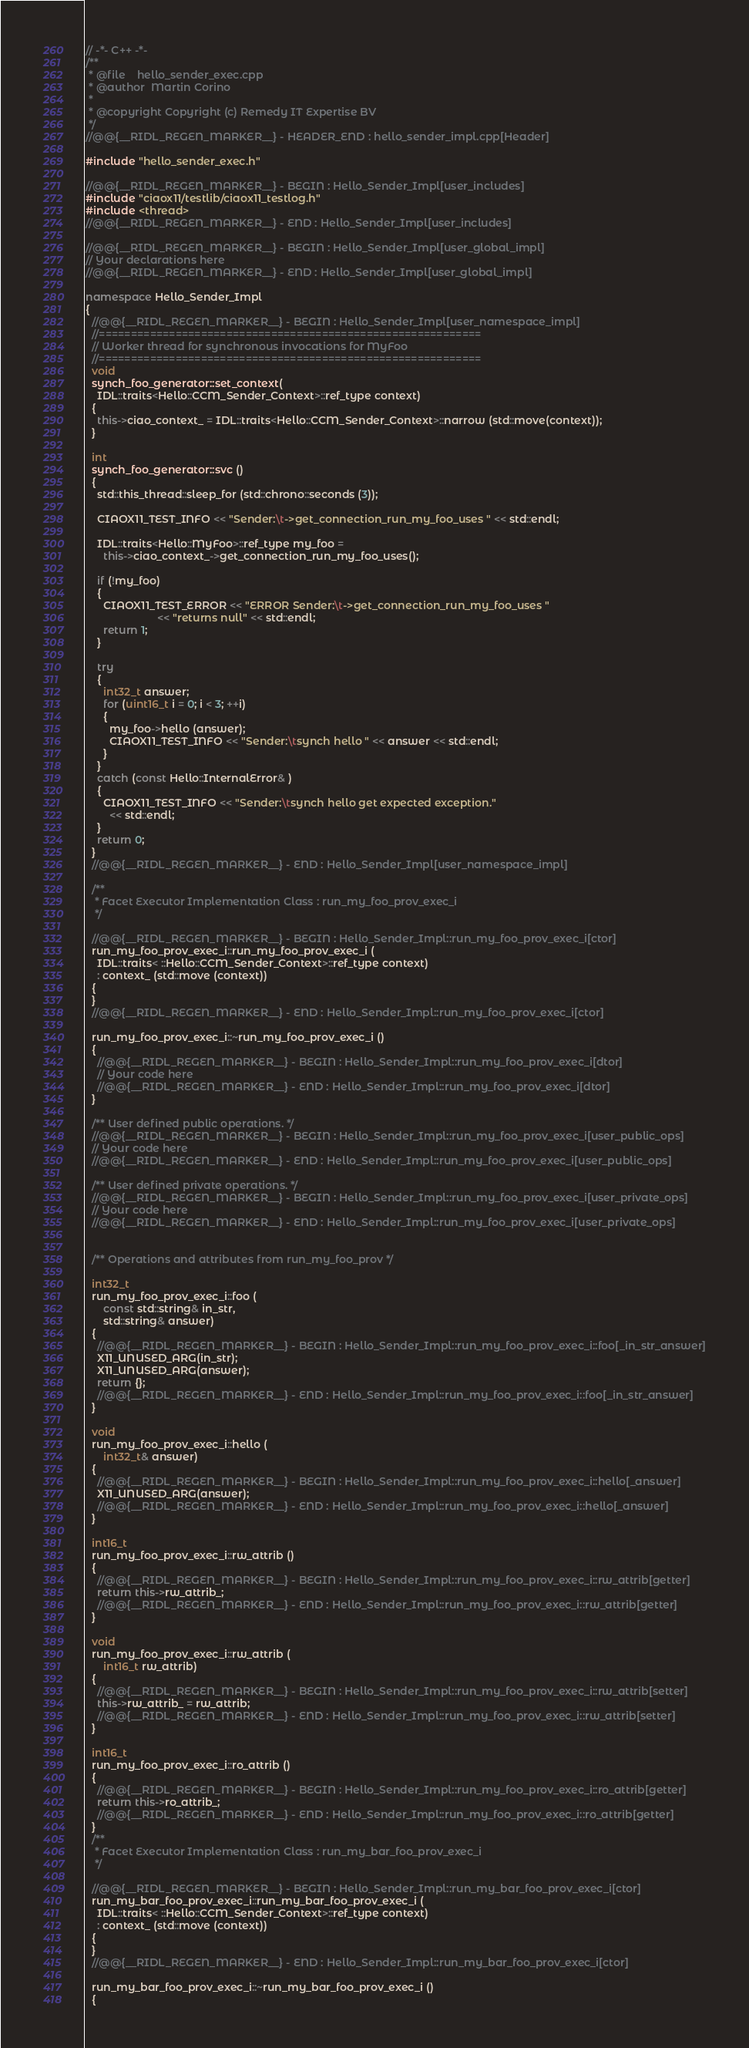<code> <loc_0><loc_0><loc_500><loc_500><_C++_>// -*- C++ -*-
/**
 * @file    hello_sender_exec.cpp
 * @author  Martin Corino
 *
 * @copyright Copyright (c) Remedy IT Expertise BV
 */
//@@{__RIDL_REGEN_MARKER__} - HEADER_END : hello_sender_impl.cpp[Header]

#include "hello_sender_exec.h"

//@@{__RIDL_REGEN_MARKER__} - BEGIN : Hello_Sender_Impl[user_includes]
#include "ciaox11/testlib/ciaox11_testlog.h"
#include <thread>
//@@{__RIDL_REGEN_MARKER__} - END : Hello_Sender_Impl[user_includes]

//@@{__RIDL_REGEN_MARKER__} - BEGIN : Hello_Sender_Impl[user_global_impl]
// Your declarations here
//@@{__RIDL_REGEN_MARKER__} - END : Hello_Sender_Impl[user_global_impl]

namespace Hello_Sender_Impl
{
  //@@{__RIDL_REGEN_MARKER__} - BEGIN : Hello_Sender_Impl[user_namespace_impl]
  //============================================================
  // Worker thread for synchronous invocations for MyFoo
  //============================================================
  void
  synch_foo_generator::set_context(
    IDL::traits<Hello::CCM_Sender_Context>::ref_type context)
  {
    this->ciao_context_ = IDL::traits<Hello::CCM_Sender_Context>::narrow (std::move(context));
  }

  int
  synch_foo_generator::svc ()
  {
    std::this_thread::sleep_for (std::chrono::seconds (3));

    CIAOX11_TEST_INFO << "Sender:\t->get_connection_run_my_foo_uses " << std::endl;

    IDL::traits<Hello::MyFoo>::ref_type my_foo =
      this->ciao_context_->get_connection_run_my_foo_uses();

    if (!my_foo)
    {
      CIAOX11_TEST_ERROR << "ERROR Sender:\t->get_connection_run_my_foo_uses "
                        << "returns null" << std::endl;
      return 1;
    }

    try
    {
      int32_t answer;
      for (uint16_t i = 0; i < 3; ++i)
      {
        my_foo->hello (answer);
        CIAOX11_TEST_INFO << "Sender:\tsynch hello " << answer << std::endl;
      }
    }
    catch (const Hello::InternalError& )
    {
      CIAOX11_TEST_INFO << "Sender:\tsynch hello get expected exception."
        << std::endl;
    }
    return 0;
  }
  //@@{__RIDL_REGEN_MARKER__} - END : Hello_Sender_Impl[user_namespace_impl]

  /**
   * Facet Executor Implementation Class : run_my_foo_prov_exec_i
   */

  //@@{__RIDL_REGEN_MARKER__} - BEGIN : Hello_Sender_Impl::run_my_foo_prov_exec_i[ctor]
  run_my_foo_prov_exec_i::run_my_foo_prov_exec_i (
    IDL::traits< ::Hello::CCM_Sender_Context>::ref_type context)
    : context_ (std::move (context))
  {
  }
  //@@{__RIDL_REGEN_MARKER__} - END : Hello_Sender_Impl::run_my_foo_prov_exec_i[ctor]

  run_my_foo_prov_exec_i::~run_my_foo_prov_exec_i ()
  {
    //@@{__RIDL_REGEN_MARKER__} - BEGIN : Hello_Sender_Impl::run_my_foo_prov_exec_i[dtor]
    // Your code here
    //@@{__RIDL_REGEN_MARKER__} - END : Hello_Sender_Impl::run_my_foo_prov_exec_i[dtor]
  }

  /** User defined public operations. */
  //@@{__RIDL_REGEN_MARKER__} - BEGIN : Hello_Sender_Impl::run_my_foo_prov_exec_i[user_public_ops]
  // Your code here
  //@@{__RIDL_REGEN_MARKER__} - END : Hello_Sender_Impl::run_my_foo_prov_exec_i[user_public_ops]

  /** User defined private operations. */
  //@@{__RIDL_REGEN_MARKER__} - BEGIN : Hello_Sender_Impl::run_my_foo_prov_exec_i[user_private_ops]
  // Your code here
  //@@{__RIDL_REGEN_MARKER__} - END : Hello_Sender_Impl::run_my_foo_prov_exec_i[user_private_ops]


  /** Operations and attributes from run_my_foo_prov */

  int32_t
  run_my_foo_prov_exec_i::foo (
      const std::string& in_str,
      std::string& answer)
  {
    //@@{__RIDL_REGEN_MARKER__} - BEGIN : Hello_Sender_Impl::run_my_foo_prov_exec_i::foo[_in_str_answer]
    X11_UNUSED_ARG(in_str);
    X11_UNUSED_ARG(answer);
    return {};
    //@@{__RIDL_REGEN_MARKER__} - END : Hello_Sender_Impl::run_my_foo_prov_exec_i::foo[_in_str_answer]
  }

  void
  run_my_foo_prov_exec_i::hello (
      int32_t& answer)
  {
    //@@{__RIDL_REGEN_MARKER__} - BEGIN : Hello_Sender_Impl::run_my_foo_prov_exec_i::hello[_answer]
    X11_UNUSED_ARG(answer);
    //@@{__RIDL_REGEN_MARKER__} - END : Hello_Sender_Impl::run_my_foo_prov_exec_i::hello[_answer]
  }

  int16_t
  run_my_foo_prov_exec_i::rw_attrib ()
  {
    //@@{__RIDL_REGEN_MARKER__} - BEGIN : Hello_Sender_Impl::run_my_foo_prov_exec_i::rw_attrib[getter]
    return this->rw_attrib_;
    //@@{__RIDL_REGEN_MARKER__} - END : Hello_Sender_Impl::run_my_foo_prov_exec_i::rw_attrib[getter]
  }

  void
  run_my_foo_prov_exec_i::rw_attrib (
      int16_t rw_attrib)
  {
    //@@{__RIDL_REGEN_MARKER__} - BEGIN : Hello_Sender_Impl::run_my_foo_prov_exec_i::rw_attrib[setter]
    this->rw_attrib_ = rw_attrib;
    //@@{__RIDL_REGEN_MARKER__} - END : Hello_Sender_Impl::run_my_foo_prov_exec_i::rw_attrib[setter]
  }

  int16_t
  run_my_foo_prov_exec_i::ro_attrib ()
  {
    //@@{__RIDL_REGEN_MARKER__} - BEGIN : Hello_Sender_Impl::run_my_foo_prov_exec_i::ro_attrib[getter]
    return this->ro_attrib_;
    //@@{__RIDL_REGEN_MARKER__} - END : Hello_Sender_Impl::run_my_foo_prov_exec_i::ro_attrib[getter]
  }
  /**
   * Facet Executor Implementation Class : run_my_bar_foo_prov_exec_i
   */

  //@@{__RIDL_REGEN_MARKER__} - BEGIN : Hello_Sender_Impl::run_my_bar_foo_prov_exec_i[ctor]
  run_my_bar_foo_prov_exec_i::run_my_bar_foo_prov_exec_i (
    IDL::traits< ::Hello::CCM_Sender_Context>::ref_type context)
    : context_ (std::move (context))
  {
  }
  //@@{__RIDL_REGEN_MARKER__} - END : Hello_Sender_Impl::run_my_bar_foo_prov_exec_i[ctor]

  run_my_bar_foo_prov_exec_i::~run_my_bar_foo_prov_exec_i ()
  {</code> 